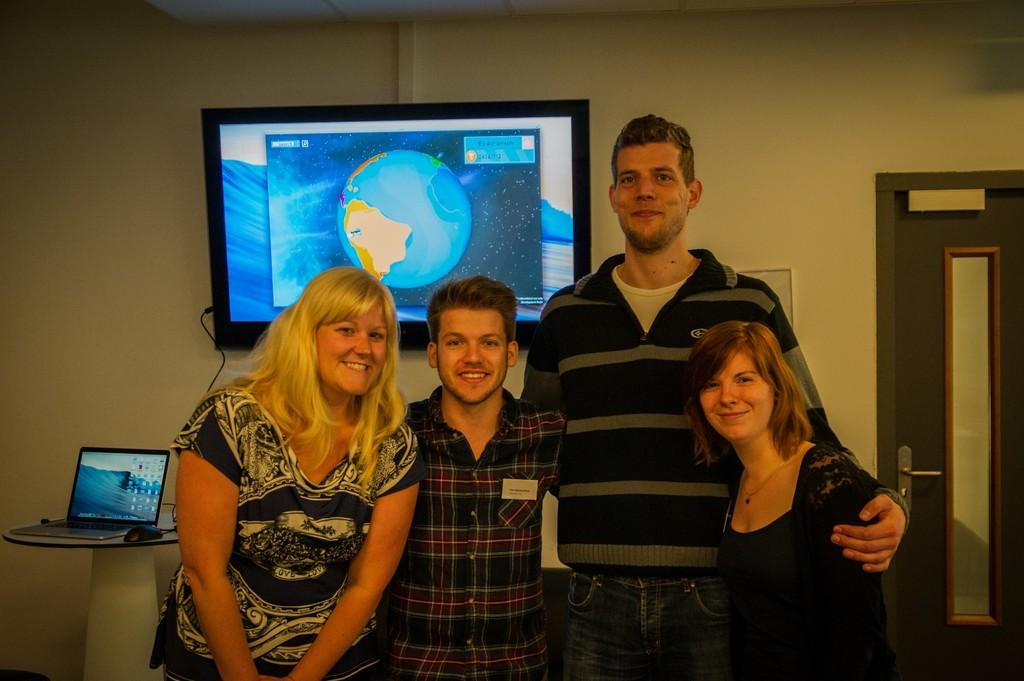How many people are in the image? There is a group of people standing in the image. What electronic device can be seen on a table in the image? There is a laptop and a mouse on a table in the image. What type of appliance is not present in the image? There is no oven present in the image. What is mounted on a wall in the image? There is a television on a wall in the image. What architectural feature is present in the image? There is a door in the image. What word is being spelled out by the people in the image? There is no indication in the image that the people are spelling out a word. --- Facts: 1. There is a car in the image. 2. The car is parked on the street. 3. There are trees in the background of the image. 4. The sky is visible in the image. 5. There is a traffic light near the car. Absurd Topics: bird, book, dance Conversation: What type of vehicle is in the image? There is a car in the image. Where is the car located? The car is parked on the street. What can be seen in the background of the image? There are trees in the background of the image. What is visible at the top of the image? The sky is visible in the image. What traffic control device is near the car? There is a traffic light near the car. Reasoning: Let's think step by step in order to produce the conversation. We start by identifying the main subject in the image, which is the car. Then, we expand the conversation to include other items that are also visible, such as the trees, the sky, and the traffic light. Each question is designed to elicit a specific detail about the image that is known from the provided facts. Absurd Question/Answer: What type of dance is being performed by the car in the image? There is no indication in the image that the car is performing a dance. 